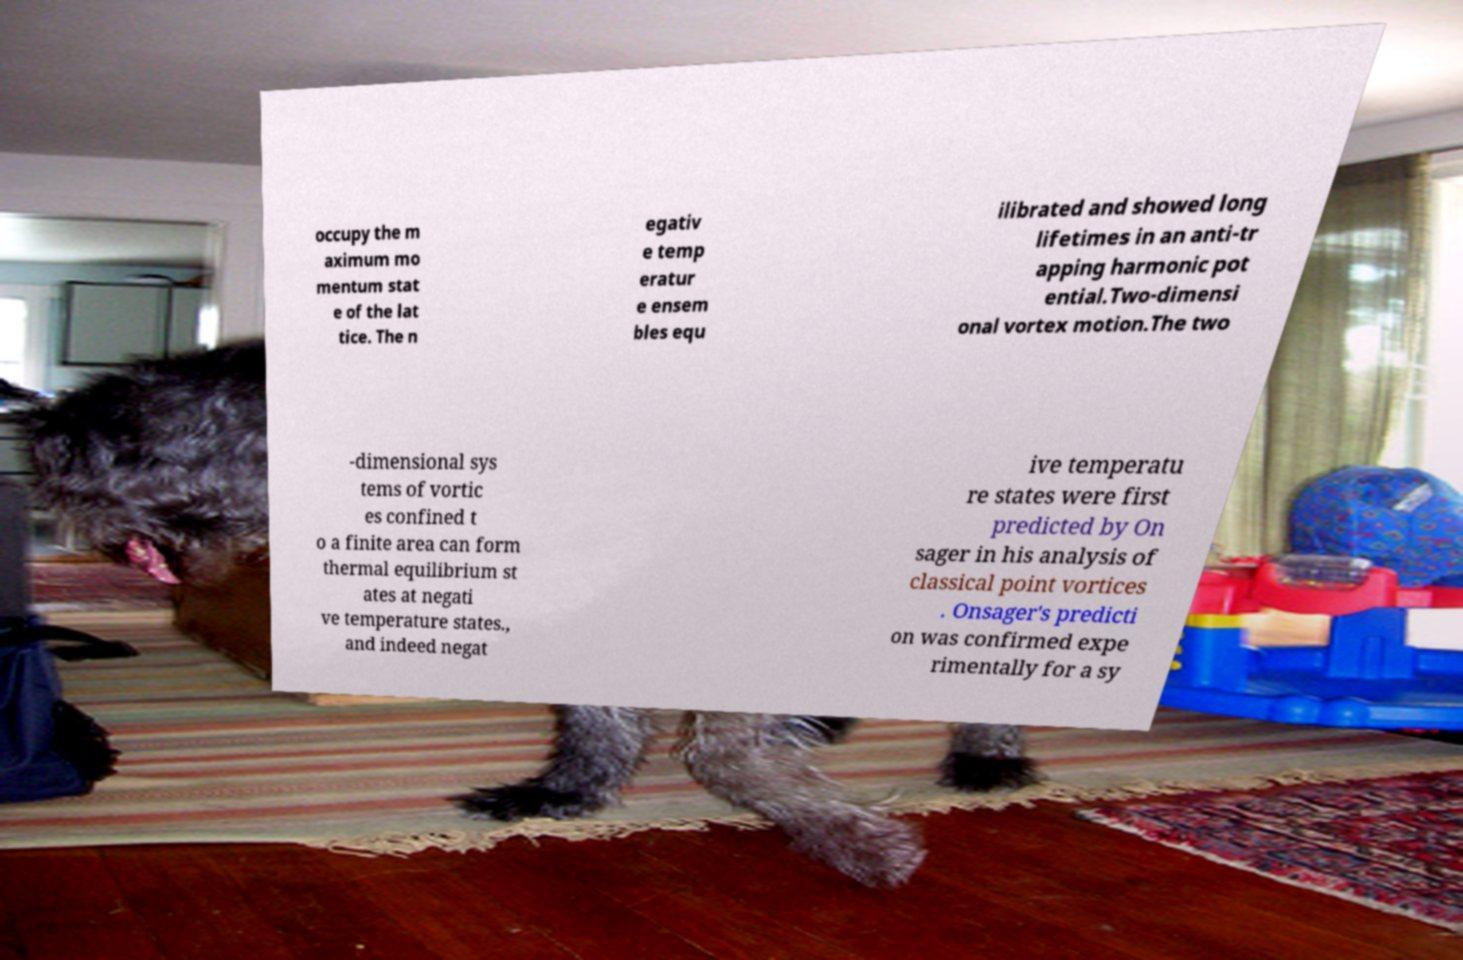Could you assist in decoding the text presented in this image and type it out clearly? occupy the m aximum mo mentum stat e of the lat tice. The n egativ e temp eratur e ensem bles equ ilibrated and showed long lifetimes in an anti-tr apping harmonic pot ential.Two-dimensi onal vortex motion.The two -dimensional sys tems of vortic es confined t o a finite area can form thermal equilibrium st ates at negati ve temperature states., and indeed negat ive temperatu re states were first predicted by On sager in his analysis of classical point vortices . Onsager's predicti on was confirmed expe rimentally for a sy 